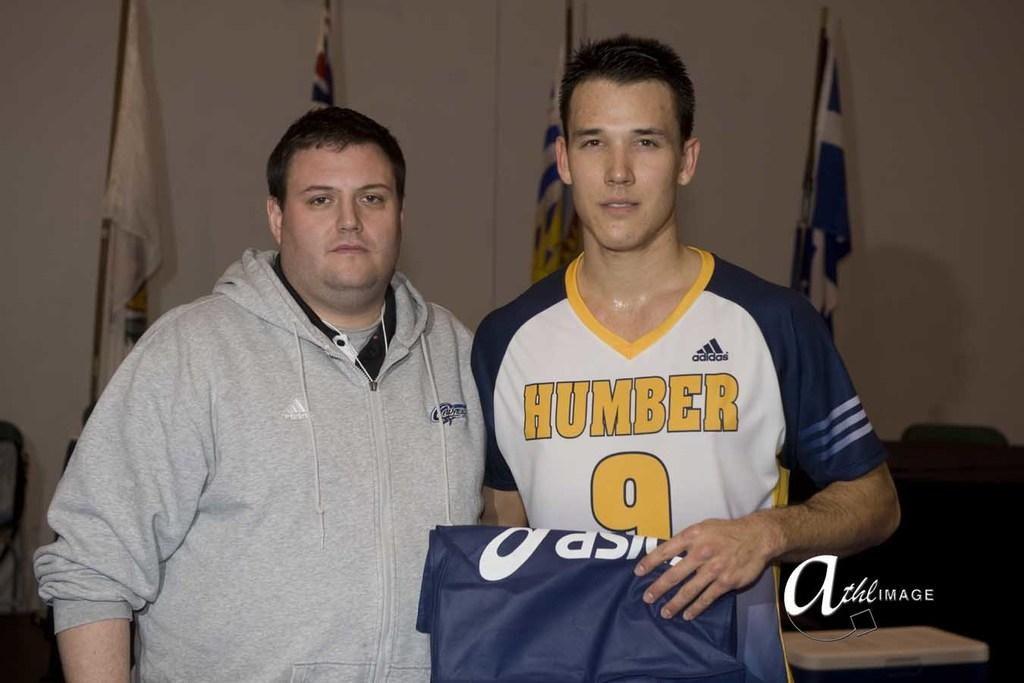<image>
Write a terse but informative summary of the picture. A player wearing a jersey from the company Adidas 